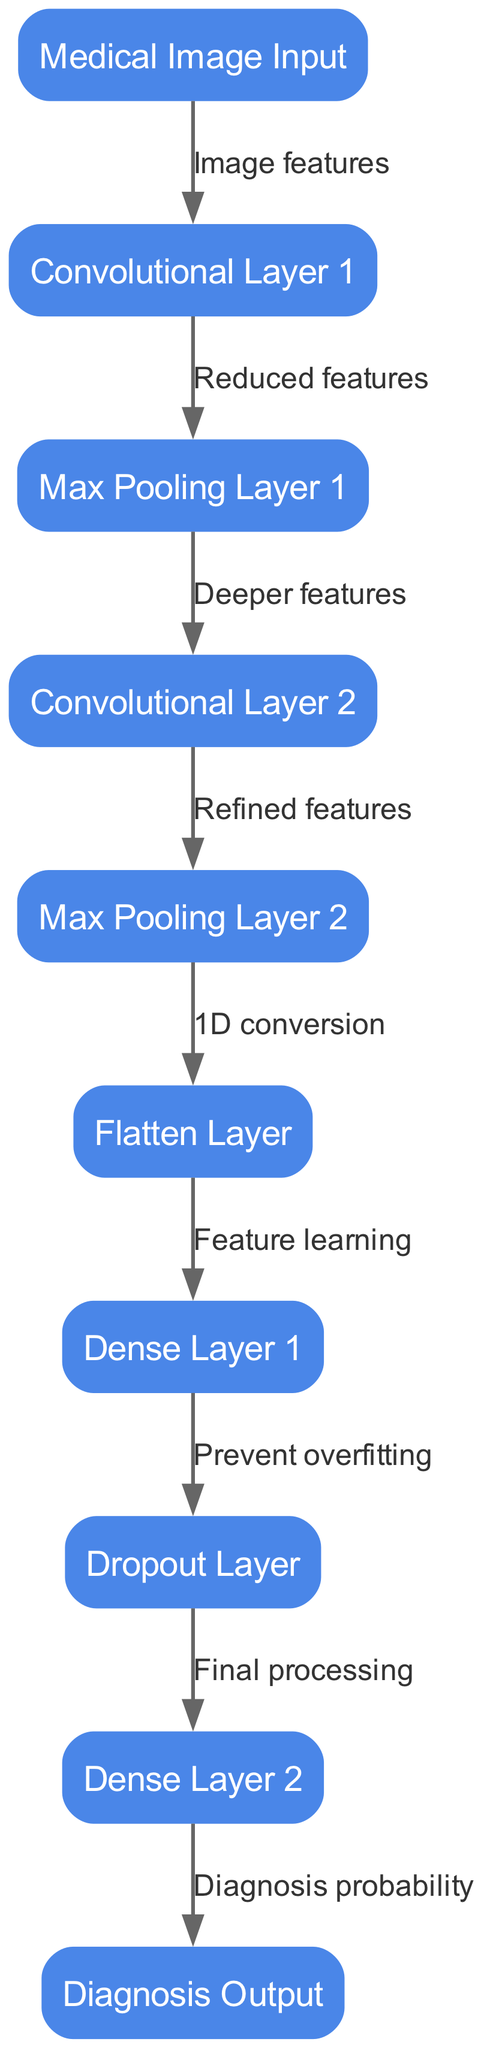What is the first layer in the neural network? The first layer in the diagram is represented by the "Medical Image Input" node, which is where the input medical image is processed first.
Answer: Medical Image Input How many convolutional layers are present in the architecture? The diagram shows two convolutional layers: "Convolutional Layer 1" and "Convolutional Layer 2," which can be counted directly from the nodes section.
Answer: 2 What process occurs after "Max Pooling Layer 1"? "Max Pooling Layer 1" connects to "Convolutional Layer 2," indicating that deeper features are processed following the first pooling layer.
Answer: Deeper features Which layer is responsible for preventing overfitting? The "Dropout Layer" is specifically designed to prevent overfitting in the neural network, as indicated in the node labels.
Answer: Dropout Layer What is the output of the network? The final output layer of the diagram is labeled as "Diagnosis Output," which indicates the result of the network's processing.
Answer: Diagnosis Output What comes after the "Flatten Layer"? Following "Flatten Layer," the next layer is "Dense Layer 1." This is deduced from the connections shown in the diagram.
Answer: Dense Layer 1 How many connections lead into the "Dense Layer 2"? "Dense Layer 2" has a single incoming connection from "Dropout Layer," which is evident in the edges description of the diagram.
Answer: 1 What type of layer follows "Max Pooling Layer 2"? The type of layer following "Max Pooling Layer 2" is "Flatten Layer," shown in the connectivity from the pooling to the flattening process in the diagram.
Answer: Flatten Layer What are the features processed in "Convolutional Layer 1"? "Convolutional Layer 1" processes "Image features" as indicated by the label on the edge connecting "Medical Image Input" to "Convolutional Layer 1."
Answer: Image features 